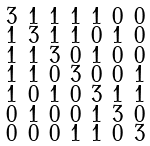<formula> <loc_0><loc_0><loc_500><loc_500>\begin{smallmatrix} 3 & 1 & 1 & 1 & 1 & 0 & 0 \\ 1 & 3 & 1 & 1 & 0 & 1 & 0 \\ 1 & 1 & 3 & 0 & 1 & 0 & 0 \\ 1 & 1 & 0 & 3 & 0 & 0 & 1 \\ 1 & 0 & 1 & 0 & 3 & 1 & 1 \\ 0 & 1 & 0 & 0 & 1 & 3 & 0 \\ 0 & 0 & 0 & 1 & 1 & 0 & 3 \end{smallmatrix}</formula> 